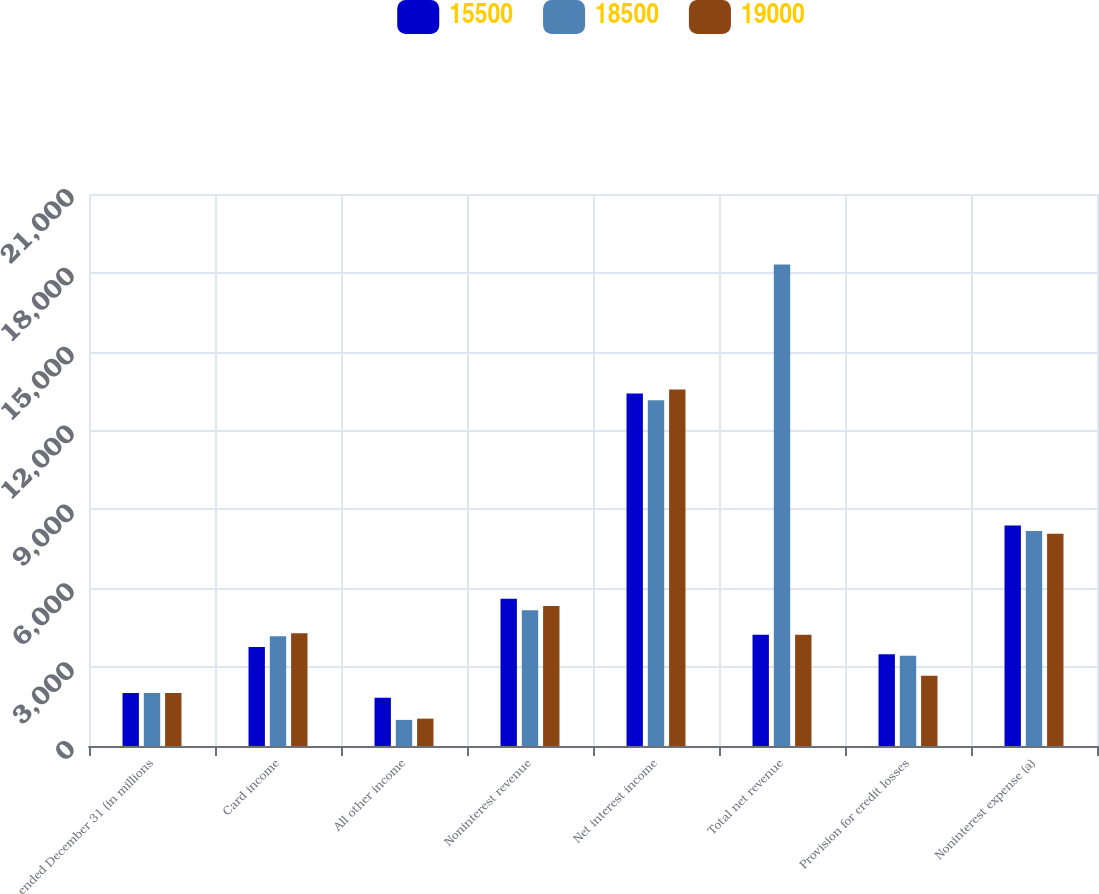<chart> <loc_0><loc_0><loc_500><loc_500><stacked_bar_chart><ecel><fcel>ended December 31 (in millions<fcel>Card income<fcel>All other income<fcel>Noninterest revenue<fcel>Net interest income<fcel>Total net revenue<fcel>Provision for credit losses<fcel>Noninterest expense (a)<nl><fcel>15500<fcel>2015<fcel>3769<fcel>1836<fcel>5605<fcel>13415<fcel>4231<fcel>3495<fcel>8386<nl><fcel>18500<fcel>2014<fcel>4173<fcel>993<fcel>5166<fcel>13150<fcel>18316<fcel>3432<fcel>8176<nl><fcel>19000<fcel>2013<fcel>4289<fcel>1041<fcel>5330<fcel>13559<fcel>4231<fcel>2669<fcel>8078<nl></chart> 